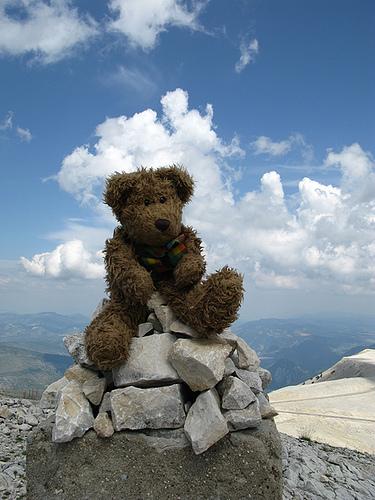Is this a live animal?
Answer briefly. No. Is this a child's toy?
Quick response, please. Yes. Is it stormy?
Write a very short answer. No. 